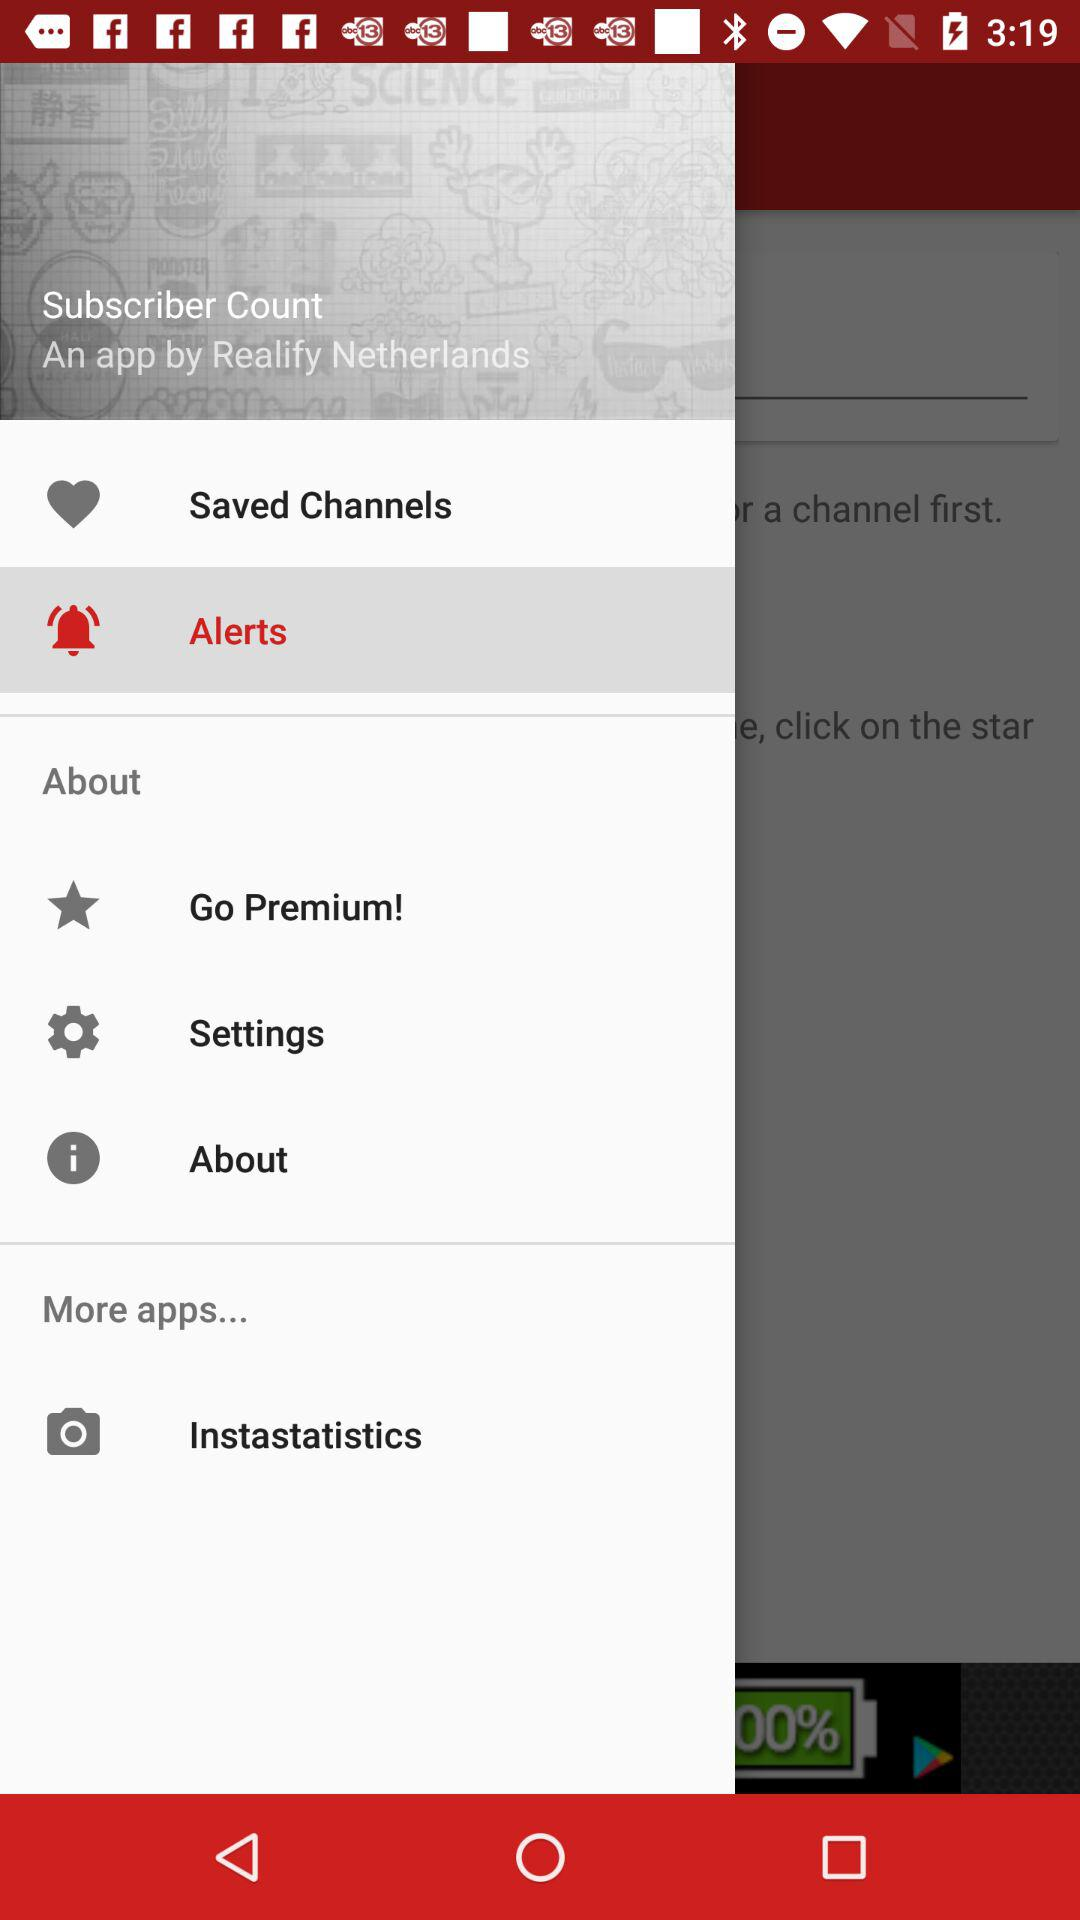How many notifications are there in "Settings"?
When the provided information is insufficient, respond with <no answer>. <no answer> 